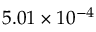<formula> <loc_0><loc_0><loc_500><loc_500>5 . 0 1 \times 1 0 ^ { - 4 }</formula> 